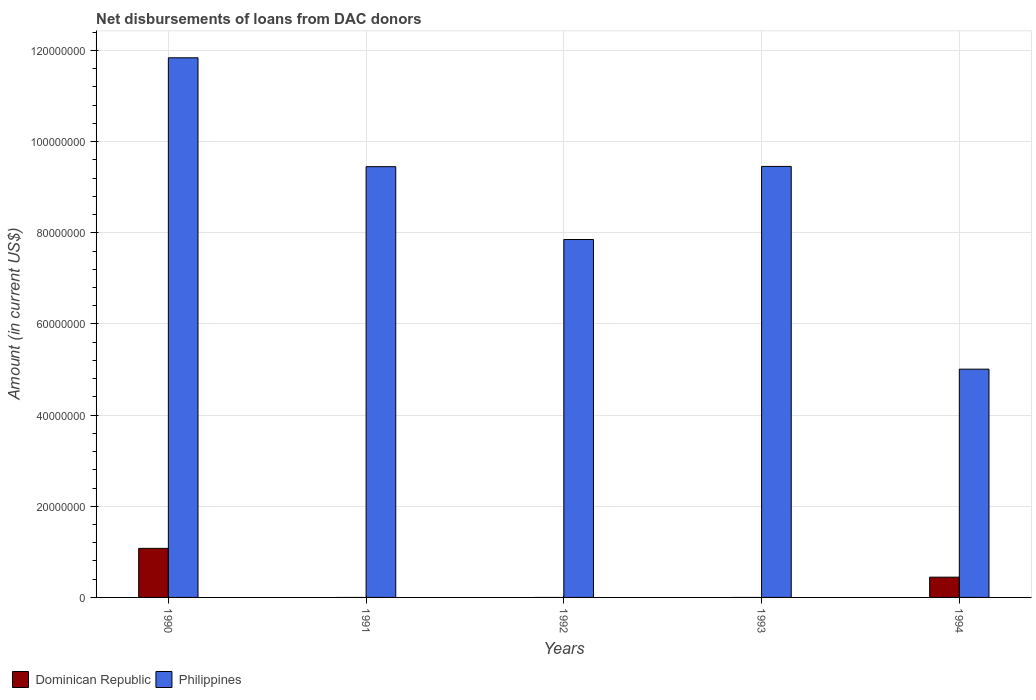How many bars are there on the 2nd tick from the left?
Your answer should be very brief. 1. How many bars are there on the 3rd tick from the right?
Your response must be concise. 1. What is the label of the 4th group of bars from the left?
Your response must be concise. 1993. What is the amount of loans disbursed in Philippines in 1990?
Make the answer very short. 1.18e+08. Across all years, what is the maximum amount of loans disbursed in Philippines?
Provide a succinct answer. 1.18e+08. Across all years, what is the minimum amount of loans disbursed in Philippines?
Your answer should be compact. 5.01e+07. What is the total amount of loans disbursed in Philippines in the graph?
Give a very brief answer. 4.36e+08. What is the difference between the amount of loans disbursed in Philippines in 1991 and that in 1992?
Give a very brief answer. 1.60e+07. What is the difference between the amount of loans disbursed in Dominican Republic in 1993 and the amount of loans disbursed in Philippines in 1994?
Offer a terse response. -5.01e+07. What is the average amount of loans disbursed in Dominican Republic per year?
Provide a succinct answer. 3.04e+06. In the year 1990, what is the difference between the amount of loans disbursed in Philippines and amount of loans disbursed in Dominican Republic?
Your response must be concise. 1.08e+08. What is the ratio of the amount of loans disbursed in Philippines in 1993 to that in 1994?
Provide a succinct answer. 1.89. What is the difference between the highest and the second highest amount of loans disbursed in Philippines?
Keep it short and to the point. 2.38e+07. What is the difference between the highest and the lowest amount of loans disbursed in Philippines?
Offer a very short reply. 6.83e+07. Are all the bars in the graph horizontal?
Make the answer very short. No. What is the difference between two consecutive major ticks on the Y-axis?
Provide a short and direct response. 2.00e+07. Are the values on the major ticks of Y-axis written in scientific E-notation?
Provide a short and direct response. No. Does the graph contain grids?
Make the answer very short. Yes. Where does the legend appear in the graph?
Ensure brevity in your answer.  Bottom left. How are the legend labels stacked?
Offer a terse response. Horizontal. What is the title of the graph?
Your answer should be compact. Net disbursements of loans from DAC donors. Does "South Sudan" appear as one of the legend labels in the graph?
Make the answer very short. No. What is the label or title of the Y-axis?
Provide a short and direct response. Amount (in current US$). What is the Amount (in current US$) in Dominican Republic in 1990?
Offer a very short reply. 1.08e+07. What is the Amount (in current US$) of Philippines in 1990?
Offer a very short reply. 1.18e+08. What is the Amount (in current US$) in Philippines in 1991?
Your answer should be very brief. 9.45e+07. What is the Amount (in current US$) of Philippines in 1992?
Ensure brevity in your answer.  7.85e+07. What is the Amount (in current US$) of Philippines in 1993?
Give a very brief answer. 9.46e+07. What is the Amount (in current US$) of Dominican Republic in 1994?
Offer a terse response. 4.44e+06. What is the Amount (in current US$) of Philippines in 1994?
Your answer should be compact. 5.01e+07. Across all years, what is the maximum Amount (in current US$) in Dominican Republic?
Ensure brevity in your answer.  1.08e+07. Across all years, what is the maximum Amount (in current US$) in Philippines?
Provide a succinct answer. 1.18e+08. Across all years, what is the minimum Amount (in current US$) in Dominican Republic?
Give a very brief answer. 0. Across all years, what is the minimum Amount (in current US$) of Philippines?
Give a very brief answer. 5.01e+07. What is the total Amount (in current US$) in Dominican Republic in the graph?
Make the answer very short. 1.52e+07. What is the total Amount (in current US$) in Philippines in the graph?
Offer a terse response. 4.36e+08. What is the difference between the Amount (in current US$) of Philippines in 1990 and that in 1991?
Your answer should be very brief. 2.39e+07. What is the difference between the Amount (in current US$) of Philippines in 1990 and that in 1992?
Provide a short and direct response. 3.99e+07. What is the difference between the Amount (in current US$) in Philippines in 1990 and that in 1993?
Your response must be concise. 2.38e+07. What is the difference between the Amount (in current US$) of Dominican Republic in 1990 and that in 1994?
Offer a very short reply. 6.32e+06. What is the difference between the Amount (in current US$) of Philippines in 1990 and that in 1994?
Provide a succinct answer. 6.83e+07. What is the difference between the Amount (in current US$) in Philippines in 1991 and that in 1992?
Keep it short and to the point. 1.60e+07. What is the difference between the Amount (in current US$) in Philippines in 1991 and that in 1993?
Give a very brief answer. -5.50e+04. What is the difference between the Amount (in current US$) of Philippines in 1991 and that in 1994?
Offer a very short reply. 4.44e+07. What is the difference between the Amount (in current US$) in Philippines in 1992 and that in 1993?
Ensure brevity in your answer.  -1.60e+07. What is the difference between the Amount (in current US$) in Philippines in 1992 and that in 1994?
Your answer should be very brief. 2.84e+07. What is the difference between the Amount (in current US$) of Philippines in 1993 and that in 1994?
Offer a terse response. 4.45e+07. What is the difference between the Amount (in current US$) of Dominican Republic in 1990 and the Amount (in current US$) of Philippines in 1991?
Ensure brevity in your answer.  -8.37e+07. What is the difference between the Amount (in current US$) of Dominican Republic in 1990 and the Amount (in current US$) of Philippines in 1992?
Keep it short and to the point. -6.78e+07. What is the difference between the Amount (in current US$) in Dominican Republic in 1990 and the Amount (in current US$) in Philippines in 1993?
Your response must be concise. -8.38e+07. What is the difference between the Amount (in current US$) in Dominican Republic in 1990 and the Amount (in current US$) in Philippines in 1994?
Your answer should be very brief. -3.93e+07. What is the average Amount (in current US$) in Dominican Republic per year?
Make the answer very short. 3.04e+06. What is the average Amount (in current US$) in Philippines per year?
Your answer should be very brief. 8.72e+07. In the year 1990, what is the difference between the Amount (in current US$) of Dominican Republic and Amount (in current US$) of Philippines?
Your response must be concise. -1.08e+08. In the year 1994, what is the difference between the Amount (in current US$) of Dominican Republic and Amount (in current US$) of Philippines?
Keep it short and to the point. -4.56e+07. What is the ratio of the Amount (in current US$) of Philippines in 1990 to that in 1991?
Offer a very short reply. 1.25. What is the ratio of the Amount (in current US$) of Philippines in 1990 to that in 1992?
Your response must be concise. 1.51. What is the ratio of the Amount (in current US$) in Philippines in 1990 to that in 1993?
Provide a succinct answer. 1.25. What is the ratio of the Amount (in current US$) in Dominican Republic in 1990 to that in 1994?
Offer a very short reply. 2.42. What is the ratio of the Amount (in current US$) in Philippines in 1990 to that in 1994?
Your answer should be very brief. 2.36. What is the ratio of the Amount (in current US$) in Philippines in 1991 to that in 1992?
Give a very brief answer. 1.2. What is the ratio of the Amount (in current US$) in Philippines in 1991 to that in 1994?
Ensure brevity in your answer.  1.89. What is the ratio of the Amount (in current US$) of Philippines in 1992 to that in 1993?
Offer a terse response. 0.83. What is the ratio of the Amount (in current US$) of Philippines in 1992 to that in 1994?
Offer a terse response. 1.57. What is the ratio of the Amount (in current US$) of Philippines in 1993 to that in 1994?
Offer a very short reply. 1.89. What is the difference between the highest and the second highest Amount (in current US$) in Philippines?
Provide a succinct answer. 2.38e+07. What is the difference between the highest and the lowest Amount (in current US$) of Dominican Republic?
Provide a succinct answer. 1.08e+07. What is the difference between the highest and the lowest Amount (in current US$) of Philippines?
Give a very brief answer. 6.83e+07. 